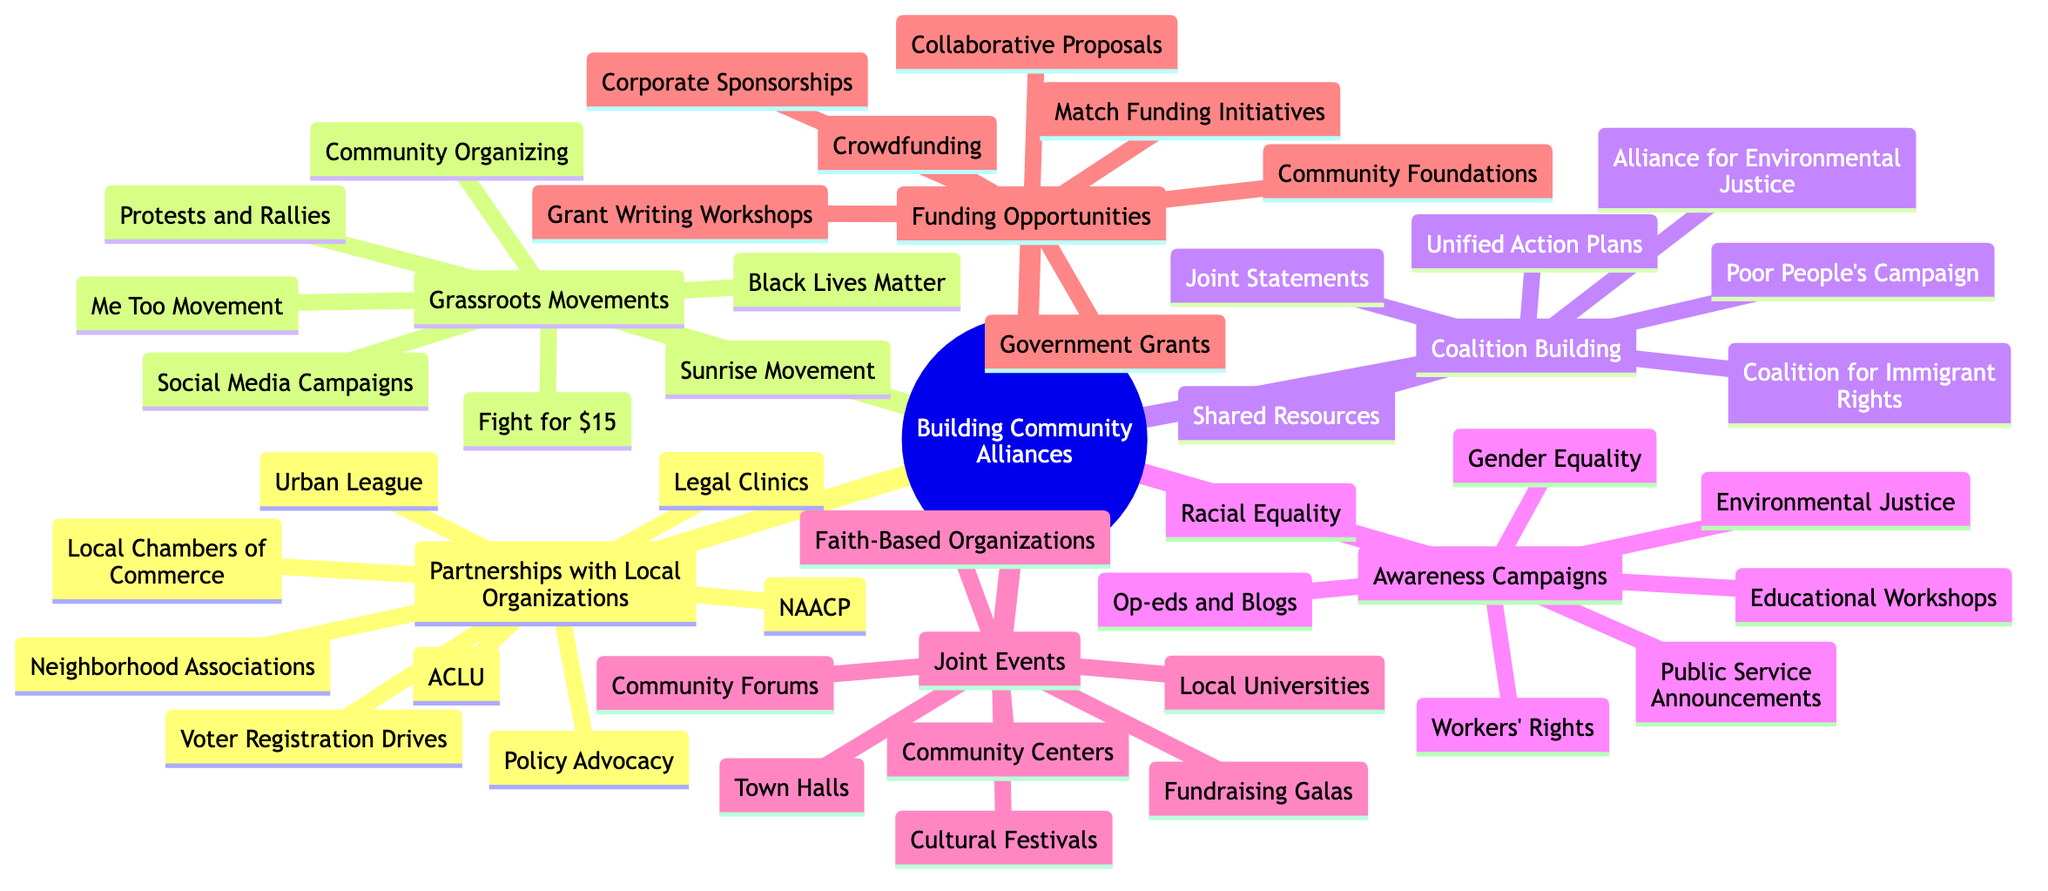What are some organizations listed under Partnerships with Local Organizations? The first part of the diagram includes a section for Partnerships with Local Organizations, which lists specific organizations that partner in community alliances. These organizations are directly mentioned in the context of partnerships.
Answer: NAACP, ACLU, Urban League, Local Chambers of Commerce, Neighborhood Associations How many Grassroots Movements are identified in the diagram? Under the Grassroots Movements section, there are four named movements listed. To find the total, you only count those explicitly mentioned under this category.
Answer: 4 What are the techniques used in Coalition Building? The Coalition Building section has a list of specific techniques for building coalitions. These techniques, included in the diagram, are critical for collaborative strategies among various groups.
Answer: Joint Statements, Shared Resources, Unified Action Plans Which theme is related to Awareness Campaigns? The Awareness Campaigns section outlines several themes that pertain to social issues. By reviewing this list, you can identify various themes that are critical to social justice advocacy.
Answer: Racial Equality, Gender Equality, Workers’ Rights, Environmental Justice What types of events are involved in Joint Events? In the Joint Events section, there is a list of different event types that can facilitate community engagement and partnership building. By examining this list, you can discern the types of events recognized in the mind map.
Answer: Town Halls, Community Forums, Fundraising Galas, Cultural Festivals Which source is a funding opportunity that could be utilized for grassroots initiatives? The Funding Opportunities section offers different sources for acquiring funds. By reviewing this section, one can recognize various potential funding sources that could support community efforts.
Answer: Community Foundations, Corporate Sponsorships, Government Grants, Crowdfunding What are collaborative proposals a part of? In the Funding Opportunities section, the strategy includes collaborative proposals, indicating a specific method used to secure funding that leverages partnerships among organizations.
Answer: Strategy What types of organizations are involved in Joint Events? The Participating Entities section of the Joint Events area lists several types of organizations that can participate in community events, revealing who is likely to engage in those events.
Answer: Local Universities, Faith-Based Organizations, Community Centers 